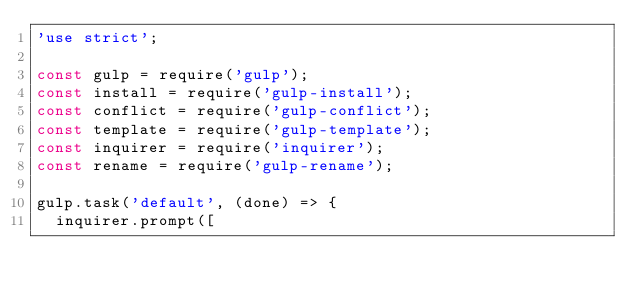<code> <loc_0><loc_0><loc_500><loc_500><_JavaScript_>'use strict';

const gulp = require('gulp');
const install = require('gulp-install');
const conflict = require('gulp-conflict');
const template = require('gulp-template');
const inquirer = require('inquirer');
const rename = require('gulp-rename');

gulp.task('default', (done) => {
  inquirer.prompt([</code> 